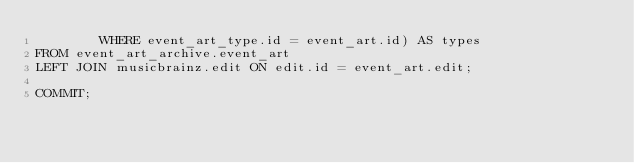<code> <loc_0><loc_0><loc_500><loc_500><_SQL_>        WHERE event_art_type.id = event_art.id) AS types
FROM event_art_archive.event_art
LEFT JOIN musicbrainz.edit ON edit.id = event_art.edit;

COMMIT;
</code> 